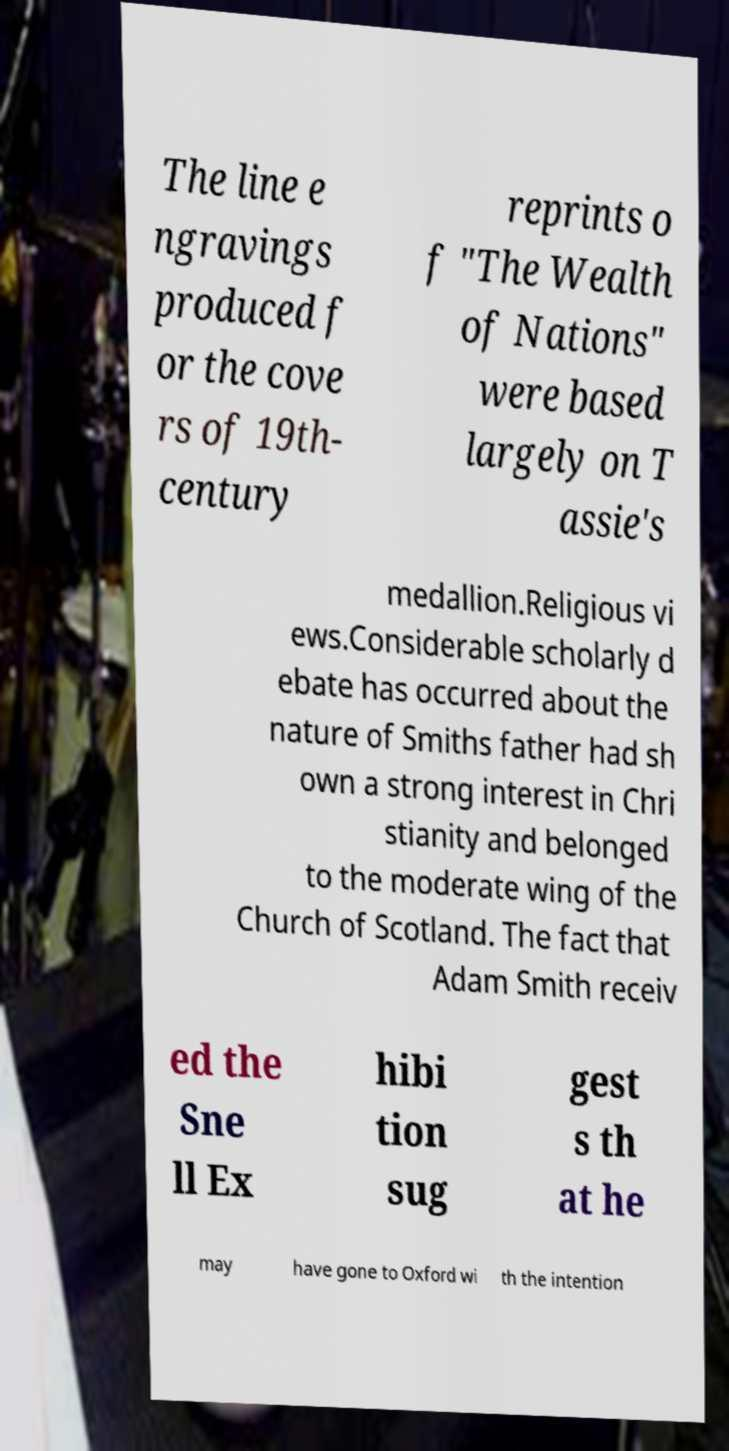Please identify and transcribe the text found in this image. The line e ngravings produced f or the cove rs of 19th- century reprints o f "The Wealth of Nations" were based largely on T assie's medallion.Religious vi ews.Considerable scholarly d ebate has occurred about the nature of Smiths father had sh own a strong interest in Chri stianity and belonged to the moderate wing of the Church of Scotland. The fact that Adam Smith receiv ed the Sne ll Ex hibi tion sug gest s th at he may have gone to Oxford wi th the intention 